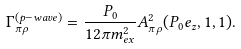Convert formula to latex. <formula><loc_0><loc_0><loc_500><loc_500>\Gamma _ { \pi \rho } ^ { ( p - w a v e ) } = \frac { P _ { 0 } } { 1 2 \pi m ^ { 2 } _ { e x } } A ^ { 2 } _ { \pi \rho } ( P _ { 0 } e _ { z } , 1 , 1 ) .</formula> 